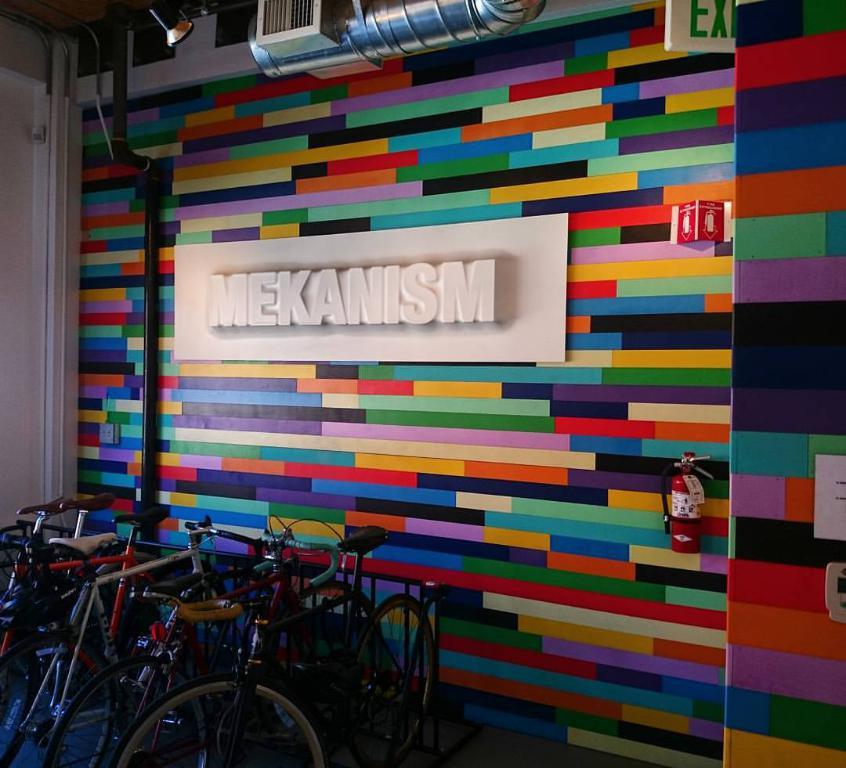<image>
Provide a brief description of the given image. A colorful wall has Mekanism in white in the center. 